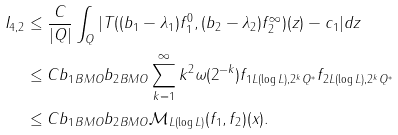Convert formula to latex. <formula><loc_0><loc_0><loc_500><loc_500>I _ { 4 , 2 } & \leq \frac { C } { | Q | } \int _ { Q } | T ( ( b _ { 1 } - \lambda _ { 1 } ) f _ { 1 } ^ { 0 } , ( b _ { 2 } - \lambda _ { 2 } ) f _ { 2 } ^ { \infty } ) ( z ) - c _ { 1 } | d z \\ & \leq { C } \| b _ { 1 } \| _ { B M O } \| b _ { 2 } \| _ { B M O } \sum _ { k = 1 } ^ { \infty } k ^ { 2 } \omega ( 2 ^ { - k } ) \| f _ { 1 } \| _ { L ( \log { L } ) , 2 ^ { k } Q ^ { * } } \| f _ { 2 } \| _ { L ( \log { L } ) , 2 ^ { k } Q ^ { * } } \\ & \leq { C } \| b _ { 1 } \| _ { B M O } \| b _ { 2 } \| _ { B M O } { \mathcal { M } } _ { L ( \log { L } ) } ( f _ { 1 } , f _ { 2 } ) ( x ) .</formula> 